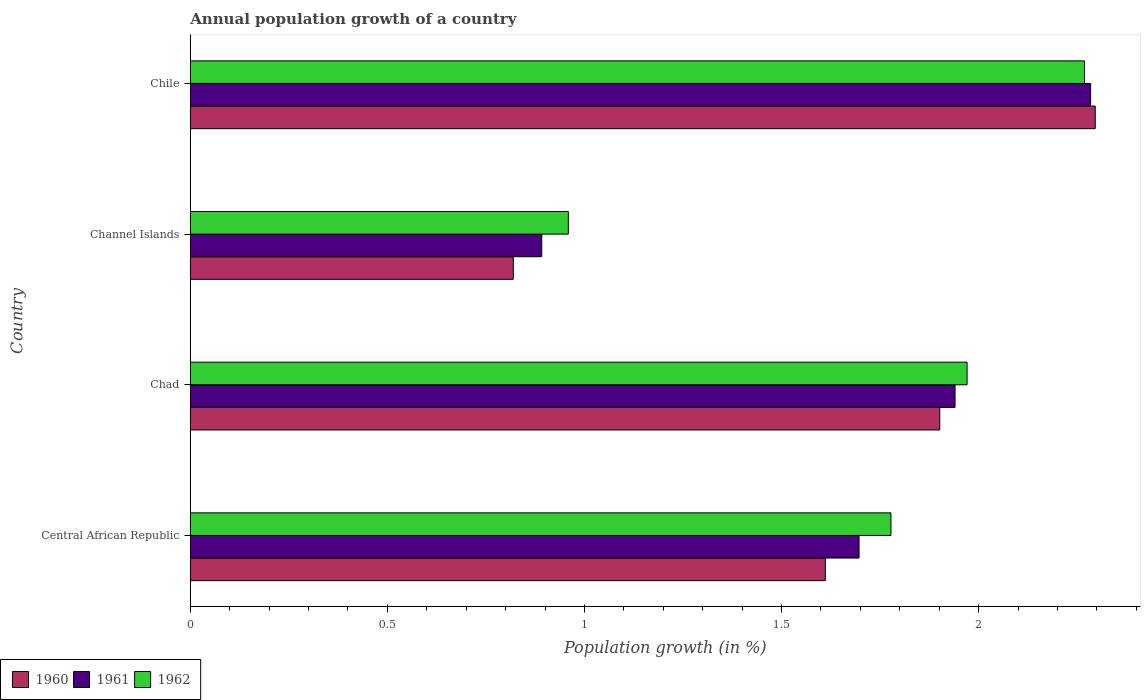How many groups of bars are there?
Offer a terse response. 4. Are the number of bars per tick equal to the number of legend labels?
Your response must be concise. Yes. Are the number of bars on each tick of the Y-axis equal?
Give a very brief answer. Yes. How many bars are there on the 4th tick from the bottom?
Ensure brevity in your answer.  3. What is the label of the 4th group of bars from the top?
Give a very brief answer. Central African Republic. What is the annual population growth in 1962 in Chile?
Keep it short and to the point. 2.27. Across all countries, what is the maximum annual population growth in 1960?
Provide a succinct answer. 2.3. Across all countries, what is the minimum annual population growth in 1962?
Provide a short and direct response. 0.96. In which country was the annual population growth in 1960 minimum?
Provide a short and direct response. Channel Islands. What is the total annual population growth in 1961 in the graph?
Ensure brevity in your answer.  6.81. What is the difference between the annual population growth in 1960 in Central African Republic and that in Channel Islands?
Give a very brief answer. 0.79. What is the difference between the annual population growth in 1962 in Central African Republic and the annual population growth in 1961 in Chad?
Provide a succinct answer. -0.16. What is the average annual population growth in 1960 per country?
Your answer should be compact. 1.66. What is the difference between the annual population growth in 1961 and annual population growth in 1962 in Chad?
Make the answer very short. -0.03. What is the ratio of the annual population growth in 1960 in Central African Republic to that in Chad?
Offer a very short reply. 0.85. Is the annual population growth in 1961 in Channel Islands less than that in Chile?
Offer a terse response. Yes. Is the difference between the annual population growth in 1961 in Central African Republic and Chile greater than the difference between the annual population growth in 1962 in Central African Republic and Chile?
Provide a succinct answer. No. What is the difference between the highest and the second highest annual population growth in 1960?
Offer a terse response. 0.39. What is the difference between the highest and the lowest annual population growth in 1960?
Your response must be concise. 1.48. In how many countries, is the annual population growth in 1962 greater than the average annual population growth in 1962 taken over all countries?
Give a very brief answer. 3. How many countries are there in the graph?
Ensure brevity in your answer.  4. Does the graph contain any zero values?
Provide a short and direct response. No. Where does the legend appear in the graph?
Ensure brevity in your answer.  Bottom left. How are the legend labels stacked?
Your answer should be compact. Horizontal. What is the title of the graph?
Provide a succinct answer. Annual population growth of a country. Does "1969" appear as one of the legend labels in the graph?
Keep it short and to the point. No. What is the label or title of the X-axis?
Offer a very short reply. Population growth (in %). What is the Population growth (in %) in 1960 in Central African Republic?
Give a very brief answer. 1.61. What is the Population growth (in %) in 1961 in Central African Republic?
Offer a very short reply. 1.7. What is the Population growth (in %) in 1962 in Central African Republic?
Keep it short and to the point. 1.78. What is the Population growth (in %) of 1960 in Chad?
Keep it short and to the point. 1.9. What is the Population growth (in %) in 1961 in Chad?
Your answer should be very brief. 1.94. What is the Population growth (in %) of 1962 in Chad?
Your answer should be very brief. 1.97. What is the Population growth (in %) of 1960 in Channel Islands?
Make the answer very short. 0.82. What is the Population growth (in %) in 1961 in Channel Islands?
Offer a very short reply. 0.89. What is the Population growth (in %) of 1962 in Channel Islands?
Your response must be concise. 0.96. What is the Population growth (in %) in 1960 in Chile?
Offer a very short reply. 2.3. What is the Population growth (in %) of 1961 in Chile?
Provide a short and direct response. 2.28. What is the Population growth (in %) in 1962 in Chile?
Give a very brief answer. 2.27. Across all countries, what is the maximum Population growth (in %) of 1960?
Give a very brief answer. 2.3. Across all countries, what is the maximum Population growth (in %) in 1961?
Provide a short and direct response. 2.28. Across all countries, what is the maximum Population growth (in %) of 1962?
Keep it short and to the point. 2.27. Across all countries, what is the minimum Population growth (in %) in 1960?
Make the answer very short. 0.82. Across all countries, what is the minimum Population growth (in %) in 1961?
Provide a short and direct response. 0.89. Across all countries, what is the minimum Population growth (in %) in 1962?
Offer a very short reply. 0.96. What is the total Population growth (in %) in 1960 in the graph?
Provide a succinct answer. 6.63. What is the total Population growth (in %) in 1961 in the graph?
Provide a short and direct response. 6.81. What is the total Population growth (in %) in 1962 in the graph?
Your answer should be compact. 6.98. What is the difference between the Population growth (in %) of 1960 in Central African Republic and that in Chad?
Offer a terse response. -0.29. What is the difference between the Population growth (in %) in 1961 in Central African Republic and that in Chad?
Offer a terse response. -0.24. What is the difference between the Population growth (in %) in 1962 in Central African Republic and that in Chad?
Your answer should be very brief. -0.19. What is the difference between the Population growth (in %) in 1960 in Central African Republic and that in Channel Islands?
Provide a short and direct response. 0.79. What is the difference between the Population growth (in %) in 1961 in Central African Republic and that in Channel Islands?
Provide a succinct answer. 0.81. What is the difference between the Population growth (in %) of 1962 in Central African Republic and that in Channel Islands?
Make the answer very short. 0.82. What is the difference between the Population growth (in %) in 1960 in Central African Republic and that in Chile?
Your answer should be very brief. -0.68. What is the difference between the Population growth (in %) in 1961 in Central African Republic and that in Chile?
Ensure brevity in your answer.  -0.59. What is the difference between the Population growth (in %) in 1962 in Central African Republic and that in Chile?
Your answer should be compact. -0.49. What is the difference between the Population growth (in %) of 1960 in Chad and that in Channel Islands?
Make the answer very short. 1.08. What is the difference between the Population growth (in %) in 1961 in Chad and that in Channel Islands?
Make the answer very short. 1.05. What is the difference between the Population growth (in %) of 1962 in Chad and that in Channel Islands?
Your response must be concise. 1.01. What is the difference between the Population growth (in %) in 1960 in Chad and that in Chile?
Keep it short and to the point. -0.39. What is the difference between the Population growth (in %) in 1961 in Chad and that in Chile?
Give a very brief answer. -0.34. What is the difference between the Population growth (in %) of 1962 in Chad and that in Chile?
Your response must be concise. -0.3. What is the difference between the Population growth (in %) of 1960 in Channel Islands and that in Chile?
Provide a short and direct response. -1.48. What is the difference between the Population growth (in %) in 1961 in Channel Islands and that in Chile?
Your answer should be compact. -1.39. What is the difference between the Population growth (in %) in 1962 in Channel Islands and that in Chile?
Keep it short and to the point. -1.31. What is the difference between the Population growth (in %) in 1960 in Central African Republic and the Population growth (in %) in 1961 in Chad?
Ensure brevity in your answer.  -0.33. What is the difference between the Population growth (in %) in 1960 in Central African Republic and the Population growth (in %) in 1962 in Chad?
Keep it short and to the point. -0.36. What is the difference between the Population growth (in %) in 1961 in Central African Republic and the Population growth (in %) in 1962 in Chad?
Provide a short and direct response. -0.27. What is the difference between the Population growth (in %) in 1960 in Central African Republic and the Population growth (in %) in 1961 in Channel Islands?
Your answer should be compact. 0.72. What is the difference between the Population growth (in %) of 1960 in Central African Republic and the Population growth (in %) of 1962 in Channel Islands?
Offer a very short reply. 0.65. What is the difference between the Population growth (in %) of 1961 in Central African Republic and the Population growth (in %) of 1962 in Channel Islands?
Your response must be concise. 0.74. What is the difference between the Population growth (in %) of 1960 in Central African Republic and the Population growth (in %) of 1961 in Chile?
Provide a succinct answer. -0.67. What is the difference between the Population growth (in %) in 1960 in Central African Republic and the Population growth (in %) in 1962 in Chile?
Ensure brevity in your answer.  -0.66. What is the difference between the Population growth (in %) of 1961 in Central African Republic and the Population growth (in %) of 1962 in Chile?
Ensure brevity in your answer.  -0.57. What is the difference between the Population growth (in %) of 1960 in Chad and the Population growth (in %) of 1961 in Channel Islands?
Your answer should be compact. 1.01. What is the difference between the Population growth (in %) in 1960 in Chad and the Population growth (in %) in 1962 in Channel Islands?
Keep it short and to the point. 0.94. What is the difference between the Population growth (in %) in 1961 in Chad and the Population growth (in %) in 1962 in Channel Islands?
Provide a succinct answer. 0.98. What is the difference between the Population growth (in %) of 1960 in Chad and the Population growth (in %) of 1961 in Chile?
Provide a succinct answer. -0.38. What is the difference between the Population growth (in %) of 1960 in Chad and the Population growth (in %) of 1962 in Chile?
Offer a very short reply. -0.37. What is the difference between the Population growth (in %) in 1961 in Chad and the Population growth (in %) in 1962 in Chile?
Your response must be concise. -0.33. What is the difference between the Population growth (in %) in 1960 in Channel Islands and the Population growth (in %) in 1961 in Chile?
Your answer should be very brief. -1.46. What is the difference between the Population growth (in %) in 1960 in Channel Islands and the Population growth (in %) in 1962 in Chile?
Give a very brief answer. -1.45. What is the difference between the Population growth (in %) in 1961 in Channel Islands and the Population growth (in %) in 1962 in Chile?
Offer a very short reply. -1.38. What is the average Population growth (in %) of 1960 per country?
Give a very brief answer. 1.66. What is the average Population growth (in %) in 1961 per country?
Make the answer very short. 1.7. What is the average Population growth (in %) of 1962 per country?
Your response must be concise. 1.74. What is the difference between the Population growth (in %) of 1960 and Population growth (in %) of 1961 in Central African Republic?
Your answer should be very brief. -0.09. What is the difference between the Population growth (in %) in 1960 and Population growth (in %) in 1962 in Central African Republic?
Give a very brief answer. -0.17. What is the difference between the Population growth (in %) in 1961 and Population growth (in %) in 1962 in Central African Republic?
Offer a very short reply. -0.08. What is the difference between the Population growth (in %) in 1960 and Population growth (in %) in 1961 in Chad?
Your response must be concise. -0.04. What is the difference between the Population growth (in %) in 1960 and Population growth (in %) in 1962 in Chad?
Your answer should be compact. -0.07. What is the difference between the Population growth (in %) of 1961 and Population growth (in %) of 1962 in Chad?
Provide a short and direct response. -0.03. What is the difference between the Population growth (in %) in 1960 and Population growth (in %) in 1961 in Channel Islands?
Provide a succinct answer. -0.07. What is the difference between the Population growth (in %) of 1960 and Population growth (in %) of 1962 in Channel Islands?
Give a very brief answer. -0.14. What is the difference between the Population growth (in %) in 1961 and Population growth (in %) in 1962 in Channel Islands?
Offer a very short reply. -0.07. What is the difference between the Population growth (in %) of 1960 and Population growth (in %) of 1961 in Chile?
Give a very brief answer. 0.01. What is the difference between the Population growth (in %) of 1960 and Population growth (in %) of 1962 in Chile?
Offer a very short reply. 0.03. What is the difference between the Population growth (in %) of 1961 and Population growth (in %) of 1962 in Chile?
Your response must be concise. 0.02. What is the ratio of the Population growth (in %) in 1960 in Central African Republic to that in Chad?
Keep it short and to the point. 0.85. What is the ratio of the Population growth (in %) of 1961 in Central African Republic to that in Chad?
Your response must be concise. 0.87. What is the ratio of the Population growth (in %) in 1962 in Central African Republic to that in Chad?
Offer a terse response. 0.9. What is the ratio of the Population growth (in %) in 1960 in Central African Republic to that in Channel Islands?
Give a very brief answer. 1.97. What is the ratio of the Population growth (in %) of 1961 in Central African Republic to that in Channel Islands?
Make the answer very short. 1.9. What is the ratio of the Population growth (in %) of 1962 in Central African Republic to that in Channel Islands?
Provide a short and direct response. 1.85. What is the ratio of the Population growth (in %) in 1960 in Central African Republic to that in Chile?
Keep it short and to the point. 0.7. What is the ratio of the Population growth (in %) in 1961 in Central African Republic to that in Chile?
Give a very brief answer. 0.74. What is the ratio of the Population growth (in %) of 1962 in Central African Republic to that in Chile?
Offer a terse response. 0.78. What is the ratio of the Population growth (in %) of 1960 in Chad to that in Channel Islands?
Provide a succinct answer. 2.32. What is the ratio of the Population growth (in %) in 1961 in Chad to that in Channel Islands?
Provide a succinct answer. 2.18. What is the ratio of the Population growth (in %) of 1962 in Chad to that in Channel Islands?
Make the answer very short. 2.05. What is the ratio of the Population growth (in %) of 1960 in Chad to that in Chile?
Your answer should be compact. 0.83. What is the ratio of the Population growth (in %) of 1961 in Chad to that in Chile?
Keep it short and to the point. 0.85. What is the ratio of the Population growth (in %) of 1962 in Chad to that in Chile?
Your answer should be very brief. 0.87. What is the ratio of the Population growth (in %) of 1960 in Channel Islands to that in Chile?
Offer a terse response. 0.36. What is the ratio of the Population growth (in %) of 1961 in Channel Islands to that in Chile?
Offer a terse response. 0.39. What is the ratio of the Population growth (in %) of 1962 in Channel Islands to that in Chile?
Ensure brevity in your answer.  0.42. What is the difference between the highest and the second highest Population growth (in %) of 1960?
Keep it short and to the point. 0.39. What is the difference between the highest and the second highest Population growth (in %) of 1961?
Ensure brevity in your answer.  0.34. What is the difference between the highest and the second highest Population growth (in %) of 1962?
Provide a short and direct response. 0.3. What is the difference between the highest and the lowest Population growth (in %) in 1960?
Provide a succinct answer. 1.48. What is the difference between the highest and the lowest Population growth (in %) in 1961?
Make the answer very short. 1.39. What is the difference between the highest and the lowest Population growth (in %) in 1962?
Offer a very short reply. 1.31. 